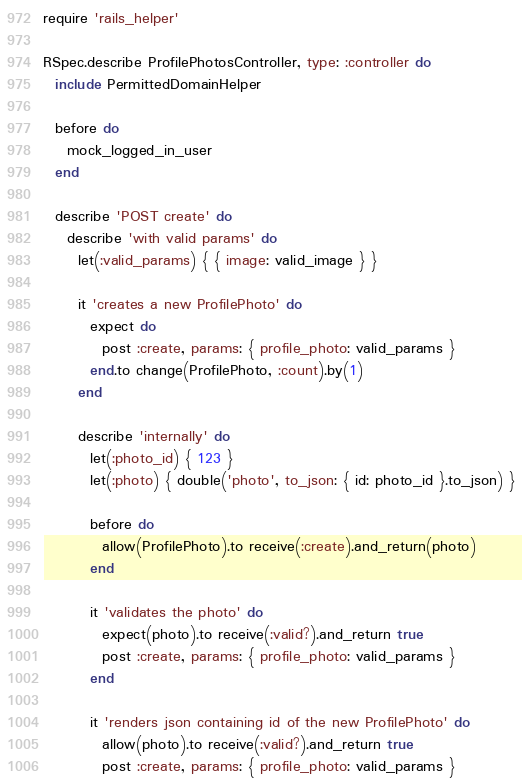<code> <loc_0><loc_0><loc_500><loc_500><_Ruby_>require 'rails_helper'

RSpec.describe ProfilePhotosController, type: :controller do
  include PermittedDomainHelper

  before do
    mock_logged_in_user
  end

  describe 'POST create' do
    describe 'with valid params' do
      let(:valid_params) { { image: valid_image } }

      it 'creates a new ProfilePhoto' do
        expect do
          post :create, params: { profile_photo: valid_params }
        end.to change(ProfilePhoto, :count).by(1)
      end

      describe 'internally' do
        let(:photo_id) { 123 }
        let(:photo) { double('photo', to_json: { id: photo_id }.to_json) }

        before do
          allow(ProfilePhoto).to receive(:create).and_return(photo)
        end

        it 'validates the photo' do
          expect(photo).to receive(:valid?).and_return true
          post :create, params: { profile_photo: valid_params }
        end

        it 'renders json containing id of the new ProfilePhoto' do
          allow(photo).to receive(:valid?).and_return true
          post :create, params: { profile_photo: valid_params }</code> 